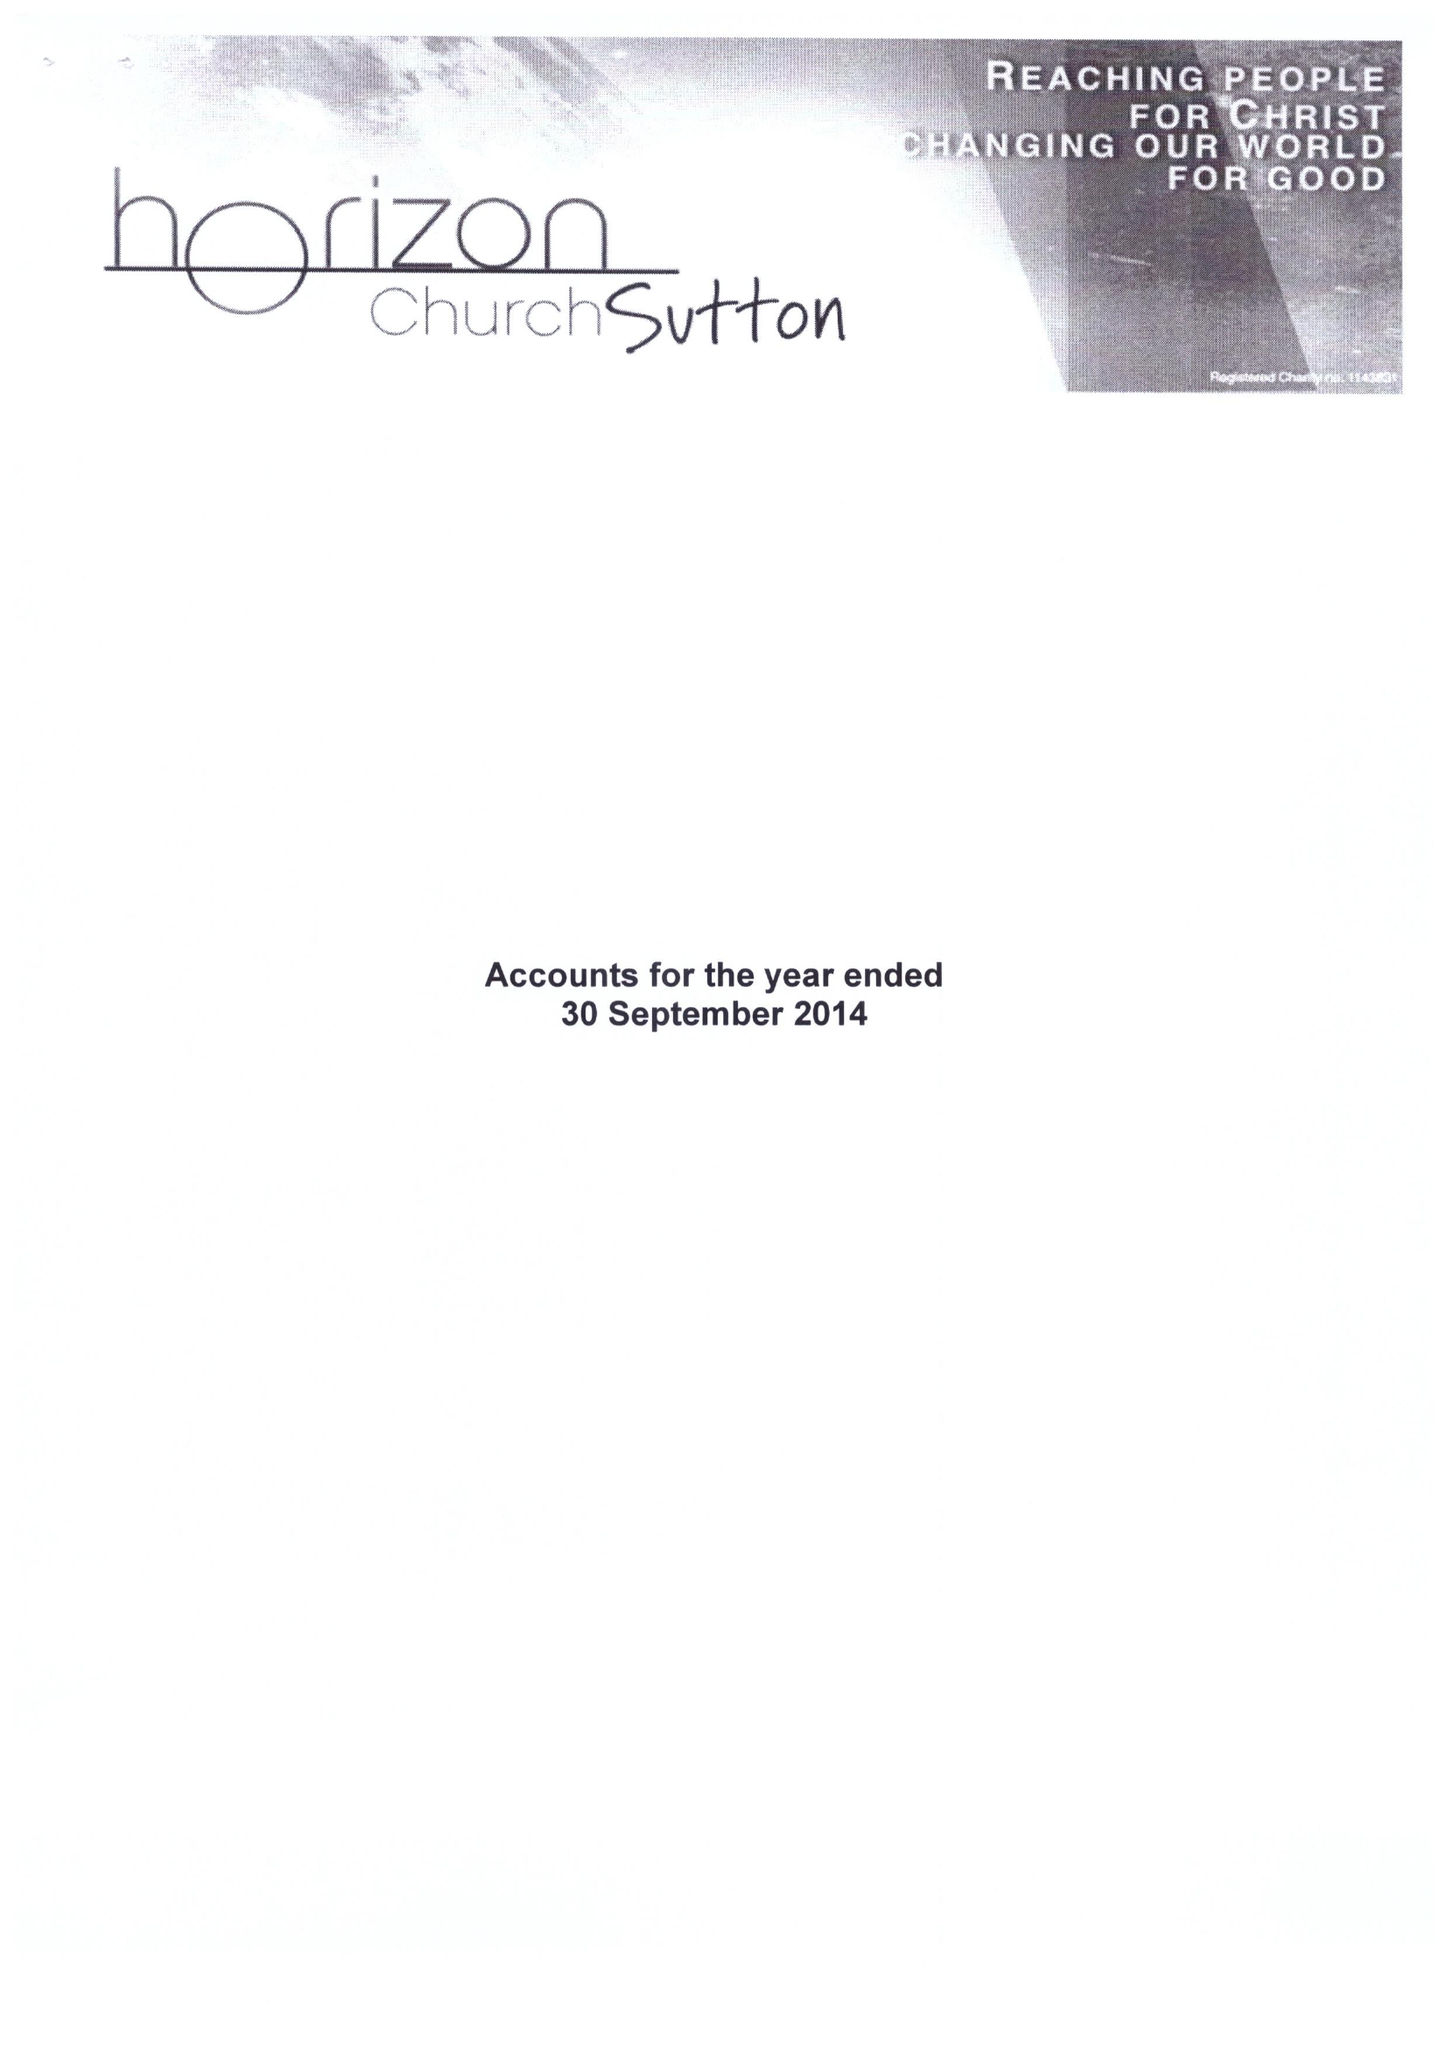What is the value for the charity_number?
Answer the question using a single word or phrase. 1143831 